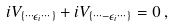Convert formula to latex. <formula><loc_0><loc_0><loc_500><loc_500>i V _ { \{ \cdots \epsilon _ { i } \cdots \} } + i V _ { \{ \cdots - \epsilon _ { i } \cdots \} } = 0 \, ,</formula> 